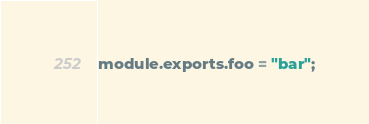Convert code to text. <code><loc_0><loc_0><loc_500><loc_500><_JavaScript_>module.exports.foo = "bar";</code> 